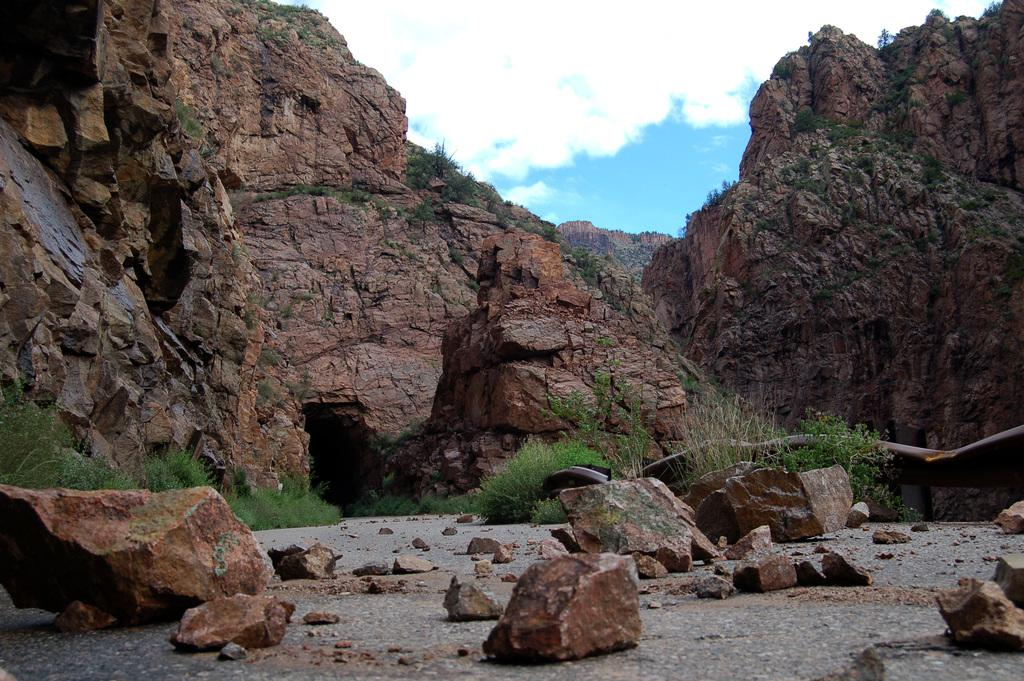What type of objects are located in the front of the image? There are stones in the front of the image. What can be seen in the center of the image? There are plants in the center of the image. What is visible in the background of the image? There are mountains in the background of the image. How would you describe the sky in the image? The sky is cloudy in the image. Can you see a goat grazing on the plants in the image? There is no goat present in the image; it features stones, plants, mountains, and a cloudy sky. What type of fish can be seen swimming in the stones in the image? There are no fish visible in the image; it only shows stones, plants, mountains, and a cloudy sky. 